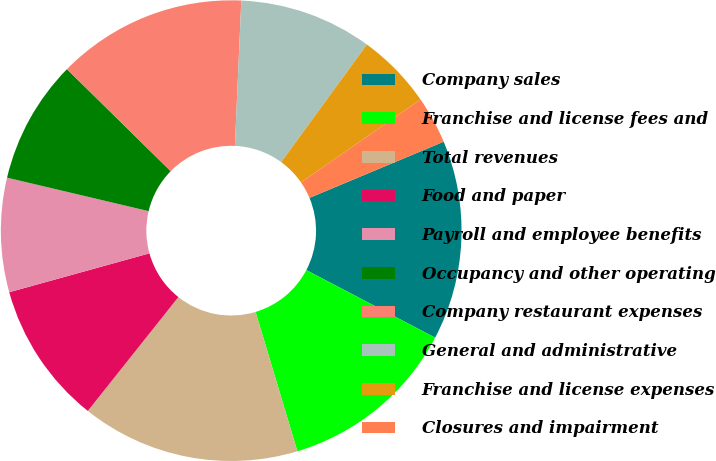Convert chart to OTSL. <chart><loc_0><loc_0><loc_500><loc_500><pie_chart><fcel>Company sales<fcel>Franchise and license fees and<fcel>Total revenues<fcel>Food and paper<fcel>Payroll and employee benefits<fcel>Occupancy and other operating<fcel>Company restaurant expenses<fcel>General and administrative<fcel>Franchise and license expenses<fcel>Closures and impairment<nl><fcel>14.0%<fcel>12.67%<fcel>15.33%<fcel>10.0%<fcel>8.0%<fcel>8.67%<fcel>13.33%<fcel>9.33%<fcel>5.33%<fcel>3.33%<nl></chart> 